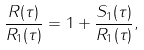Convert formula to latex. <formula><loc_0><loc_0><loc_500><loc_500>\frac { R ( \tau ) } { R _ { 1 } ( \tau ) } = 1 + \frac { S _ { 1 } ( \tau ) } { R _ { 1 } ( \tau ) } ,</formula> 